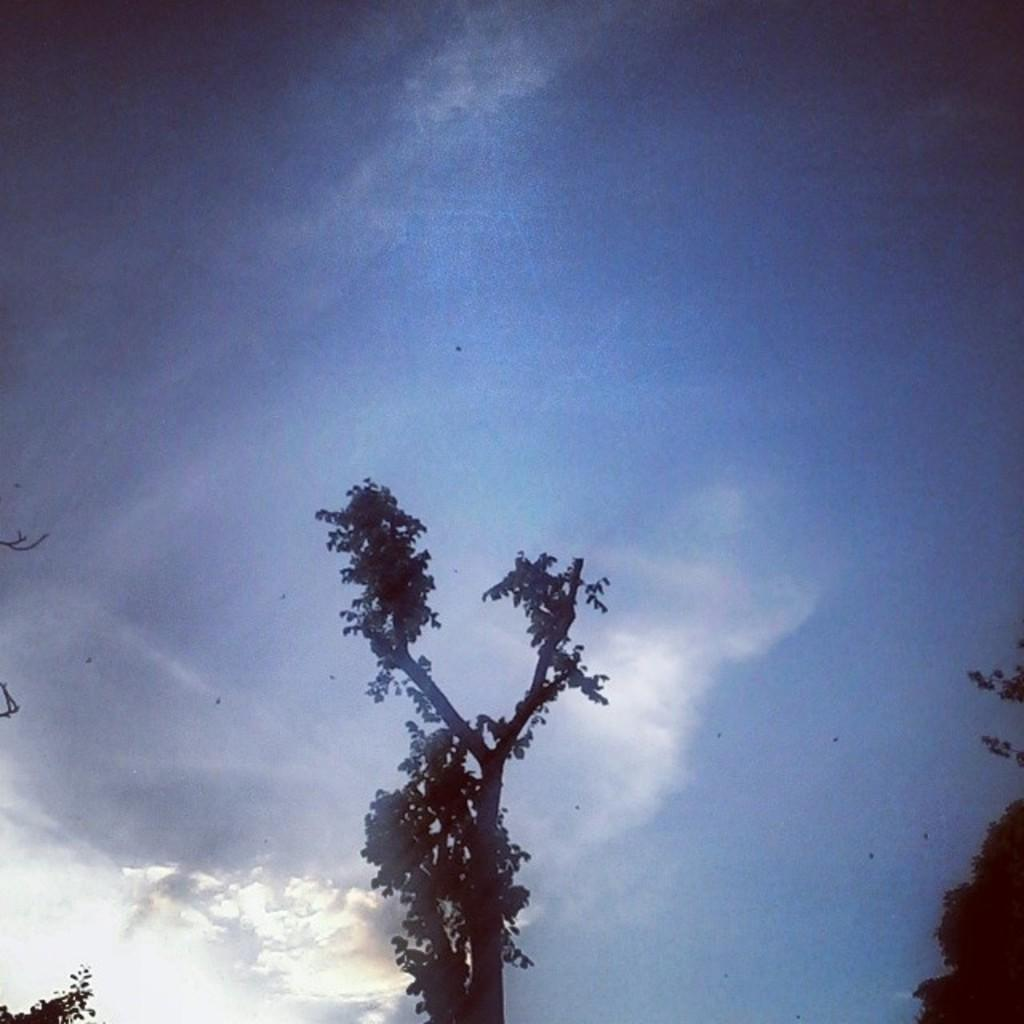What type of vegetation can be seen in the image? There are trees in the image. What is visible in the background of the image? The sky is visible in the image. What can be observed in the sky? Clouds are present in the sky. What type of oven can be seen in the image? There is no oven present in the image. How many celery stalks are visible in the image? There is no celery present in the image. 